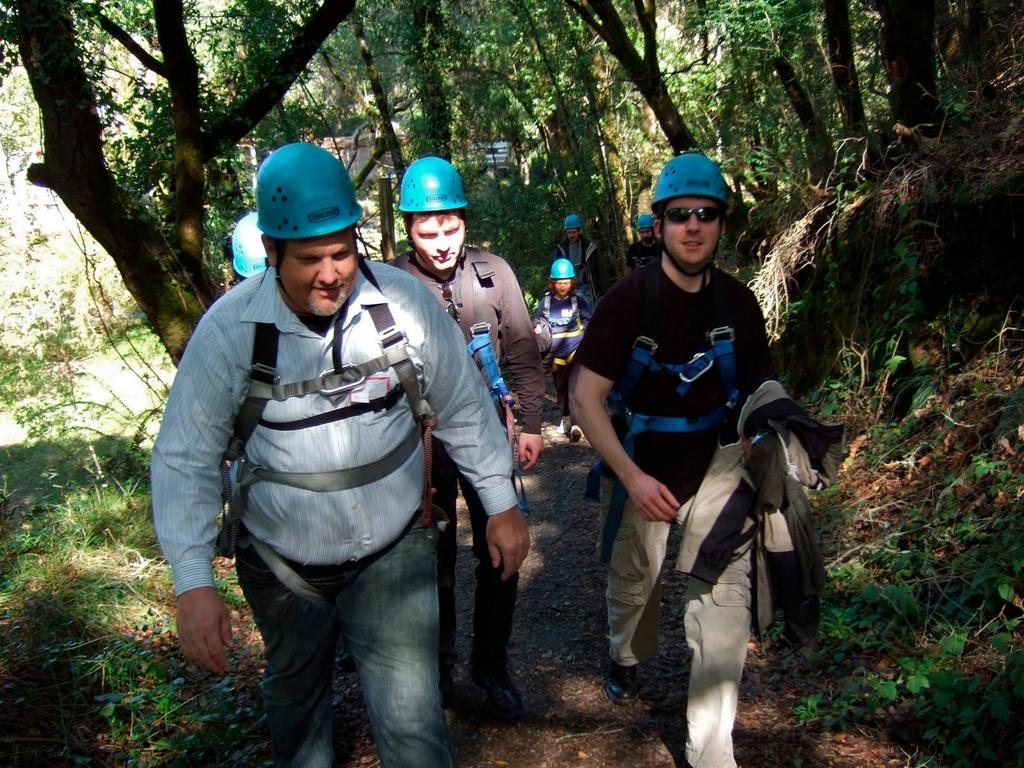Who are the people in the image? The people in the image are wearing blue helmets and blue dresses. What are the people doing in the image? The people are walking on the road. What can be seen in the background of the image? There is grass visible in the image, and there are trees on either side of the image. How many lizards are sitting on the pump in the image? There are no lizards or pumps present in the image. Who is the partner of the person walking on the road in the image? There is no indication of a partner or any other person walking on the road in the image. 